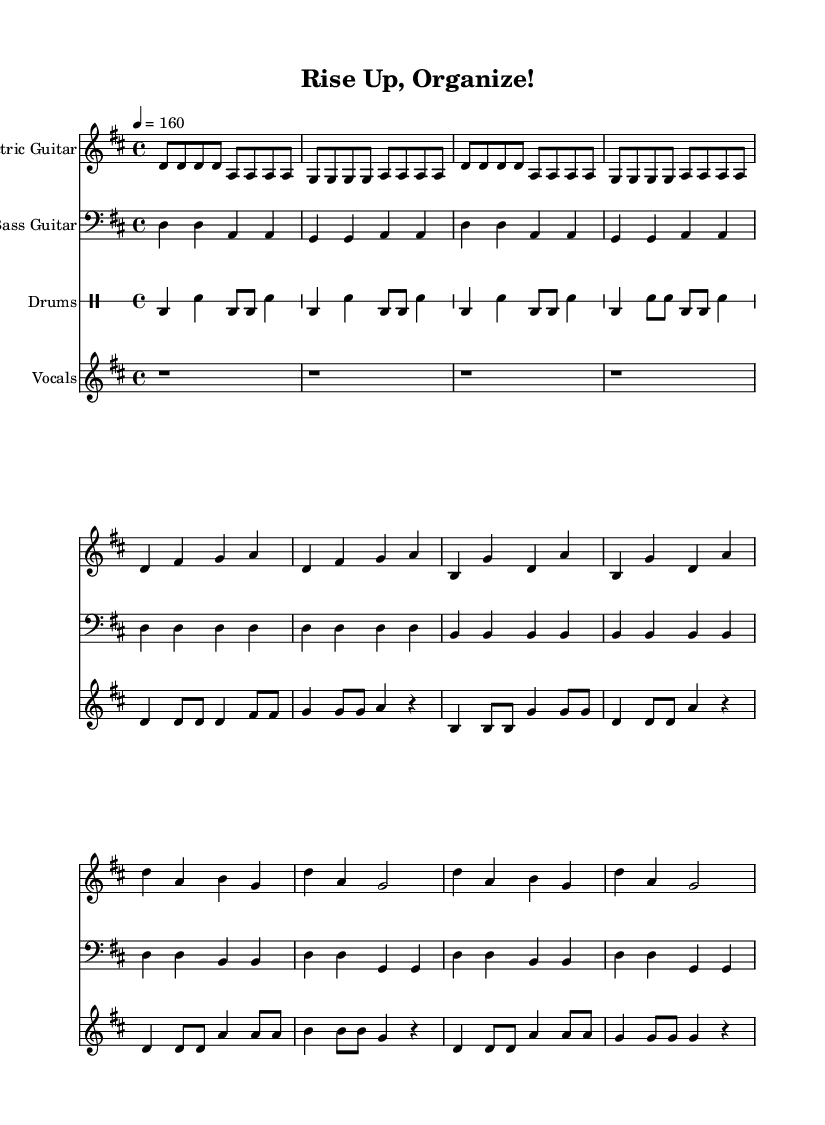What is the key signature of this music? The key signature is D major, which has two sharps (F# and C#). This can be identified by looking at the key signature at the beginning of the score.
Answer: D major What is the time signature of this music? The time signature is 4/4, which indicates that there are four beats per measure and the quarter note gets one beat. This can be found at the beginning of the score after the key signature.
Answer: 4/4 What is the tempo marking for this piece? The tempo marking indicates a speed of 160 beats per minute, which can be found specified in the score.
Answer: 160 How many measures are in the chorus section? The chorus section consists of 8 measures. This is determined by counting the measures specifically marked for the chorus in the sheet music.
Answer: 8 What type of rhythm is primarily used in the drums part? The drums part utilizes a basic punk beat, characterized by a steady bass drum and snare pattern. This can be observed by analyzing the drum notation throughout the score, which typically displays the standard punk rhythm.
Answer: Basic punk beat What instrument plays the melody in this piece? The melody is primarily conveyed by the Vocals, as indicated by the vocal staff in the sheet music that carries the lyrical lines.
Answer: Vocals What is the starting note of the electric guitar intro? The electric guitar intro starts on the note D. This is evident by looking at the first note of the electric guitar part in the score.
Answer: D 